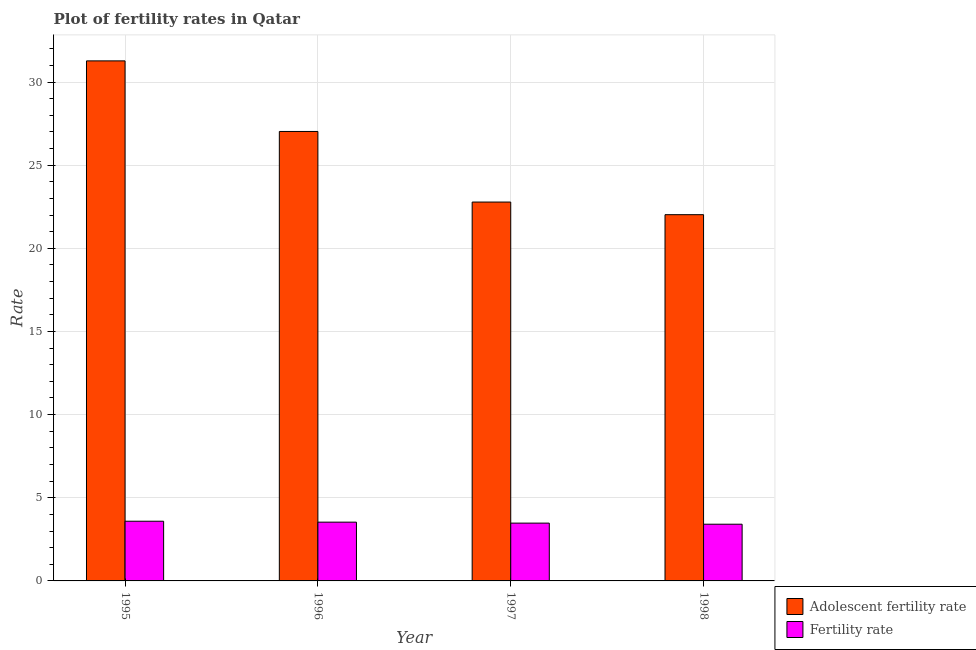How many different coloured bars are there?
Make the answer very short. 2. How many groups of bars are there?
Provide a succinct answer. 4. How many bars are there on the 2nd tick from the right?
Offer a very short reply. 2. What is the label of the 1st group of bars from the left?
Provide a short and direct response. 1995. In how many cases, is the number of bars for a given year not equal to the number of legend labels?
Ensure brevity in your answer.  0. What is the fertility rate in 1998?
Your answer should be compact. 3.41. Across all years, what is the maximum adolescent fertility rate?
Provide a succinct answer. 31.27. Across all years, what is the minimum adolescent fertility rate?
Keep it short and to the point. 22.02. In which year was the adolescent fertility rate maximum?
Provide a succinct answer. 1995. What is the total adolescent fertility rate in the graph?
Your response must be concise. 103.11. What is the difference between the fertility rate in 1995 and that in 1996?
Ensure brevity in your answer.  0.06. What is the difference between the adolescent fertility rate in 1997 and the fertility rate in 1998?
Ensure brevity in your answer.  0.76. What is the average adolescent fertility rate per year?
Your answer should be very brief. 25.78. In how many years, is the fertility rate greater than 13?
Make the answer very short. 0. What is the ratio of the fertility rate in 1996 to that in 1998?
Your answer should be compact. 1.04. What is the difference between the highest and the second highest fertility rate?
Your answer should be very brief. 0.06. What is the difference between the highest and the lowest adolescent fertility rate?
Make the answer very short. 9.25. What does the 1st bar from the left in 1995 represents?
Offer a very short reply. Adolescent fertility rate. What does the 1st bar from the right in 1995 represents?
Offer a terse response. Fertility rate. Are all the bars in the graph horizontal?
Give a very brief answer. No. What is the difference between two consecutive major ticks on the Y-axis?
Your answer should be compact. 5. Does the graph contain any zero values?
Give a very brief answer. No. Where does the legend appear in the graph?
Ensure brevity in your answer.  Bottom right. How many legend labels are there?
Keep it short and to the point. 2. What is the title of the graph?
Your answer should be very brief. Plot of fertility rates in Qatar. What is the label or title of the Y-axis?
Provide a short and direct response. Rate. What is the Rate in Adolescent fertility rate in 1995?
Offer a very short reply. 31.27. What is the Rate of Fertility rate in 1995?
Keep it short and to the point. 3.59. What is the Rate of Adolescent fertility rate in 1996?
Offer a very short reply. 27.03. What is the Rate of Fertility rate in 1996?
Make the answer very short. 3.53. What is the Rate in Adolescent fertility rate in 1997?
Offer a terse response. 22.78. What is the Rate in Fertility rate in 1997?
Your response must be concise. 3.48. What is the Rate in Adolescent fertility rate in 1998?
Make the answer very short. 22.02. What is the Rate of Fertility rate in 1998?
Provide a short and direct response. 3.41. Across all years, what is the maximum Rate of Adolescent fertility rate?
Your answer should be very brief. 31.27. Across all years, what is the maximum Rate of Fertility rate?
Provide a succinct answer. 3.59. Across all years, what is the minimum Rate of Adolescent fertility rate?
Ensure brevity in your answer.  22.02. Across all years, what is the minimum Rate in Fertility rate?
Your response must be concise. 3.41. What is the total Rate in Adolescent fertility rate in the graph?
Ensure brevity in your answer.  103.11. What is the total Rate in Fertility rate in the graph?
Provide a succinct answer. 14.01. What is the difference between the Rate in Adolescent fertility rate in 1995 and that in 1996?
Offer a terse response. 4.24. What is the difference between the Rate in Fertility rate in 1995 and that in 1996?
Your answer should be very brief. 0.06. What is the difference between the Rate in Adolescent fertility rate in 1995 and that in 1997?
Your answer should be compact. 8.49. What is the difference between the Rate in Fertility rate in 1995 and that in 1997?
Give a very brief answer. 0.11. What is the difference between the Rate in Adolescent fertility rate in 1995 and that in 1998?
Provide a short and direct response. 9.25. What is the difference between the Rate of Fertility rate in 1995 and that in 1998?
Your answer should be very brief. 0.18. What is the difference between the Rate in Adolescent fertility rate in 1996 and that in 1997?
Your response must be concise. 4.24. What is the difference between the Rate of Fertility rate in 1996 and that in 1997?
Offer a terse response. 0.06. What is the difference between the Rate in Adolescent fertility rate in 1996 and that in 1998?
Provide a succinct answer. 5. What is the difference between the Rate of Fertility rate in 1996 and that in 1998?
Ensure brevity in your answer.  0.12. What is the difference between the Rate of Adolescent fertility rate in 1997 and that in 1998?
Make the answer very short. 0.76. What is the difference between the Rate of Fertility rate in 1997 and that in 1998?
Your answer should be very brief. 0.07. What is the difference between the Rate in Adolescent fertility rate in 1995 and the Rate in Fertility rate in 1996?
Your response must be concise. 27.74. What is the difference between the Rate of Adolescent fertility rate in 1995 and the Rate of Fertility rate in 1997?
Provide a succinct answer. 27.8. What is the difference between the Rate of Adolescent fertility rate in 1995 and the Rate of Fertility rate in 1998?
Offer a terse response. 27.86. What is the difference between the Rate of Adolescent fertility rate in 1996 and the Rate of Fertility rate in 1997?
Your answer should be very brief. 23.55. What is the difference between the Rate in Adolescent fertility rate in 1996 and the Rate in Fertility rate in 1998?
Ensure brevity in your answer.  23.62. What is the difference between the Rate in Adolescent fertility rate in 1997 and the Rate in Fertility rate in 1998?
Your answer should be compact. 19.37. What is the average Rate in Adolescent fertility rate per year?
Your answer should be very brief. 25.78. What is the average Rate in Fertility rate per year?
Give a very brief answer. 3.5. In the year 1995, what is the difference between the Rate of Adolescent fertility rate and Rate of Fertility rate?
Keep it short and to the point. 27.68. In the year 1996, what is the difference between the Rate in Adolescent fertility rate and Rate in Fertility rate?
Provide a short and direct response. 23.49. In the year 1997, what is the difference between the Rate of Adolescent fertility rate and Rate of Fertility rate?
Ensure brevity in your answer.  19.31. In the year 1998, what is the difference between the Rate of Adolescent fertility rate and Rate of Fertility rate?
Offer a very short reply. 18.61. What is the ratio of the Rate of Adolescent fertility rate in 1995 to that in 1996?
Your answer should be very brief. 1.16. What is the ratio of the Rate in Fertility rate in 1995 to that in 1996?
Your answer should be compact. 1.02. What is the ratio of the Rate of Adolescent fertility rate in 1995 to that in 1997?
Offer a very short reply. 1.37. What is the ratio of the Rate of Fertility rate in 1995 to that in 1997?
Ensure brevity in your answer.  1.03. What is the ratio of the Rate in Adolescent fertility rate in 1995 to that in 1998?
Ensure brevity in your answer.  1.42. What is the ratio of the Rate in Fertility rate in 1995 to that in 1998?
Keep it short and to the point. 1.05. What is the ratio of the Rate of Adolescent fertility rate in 1996 to that in 1997?
Ensure brevity in your answer.  1.19. What is the ratio of the Rate in Fertility rate in 1996 to that in 1997?
Your answer should be very brief. 1.02. What is the ratio of the Rate of Adolescent fertility rate in 1996 to that in 1998?
Ensure brevity in your answer.  1.23. What is the ratio of the Rate in Fertility rate in 1996 to that in 1998?
Provide a succinct answer. 1.04. What is the ratio of the Rate of Adolescent fertility rate in 1997 to that in 1998?
Provide a short and direct response. 1.03. What is the ratio of the Rate of Fertility rate in 1997 to that in 1998?
Offer a terse response. 1.02. What is the difference between the highest and the second highest Rate in Adolescent fertility rate?
Your response must be concise. 4.24. What is the difference between the highest and the second highest Rate in Fertility rate?
Provide a short and direct response. 0.06. What is the difference between the highest and the lowest Rate in Adolescent fertility rate?
Your response must be concise. 9.25. What is the difference between the highest and the lowest Rate of Fertility rate?
Offer a terse response. 0.18. 